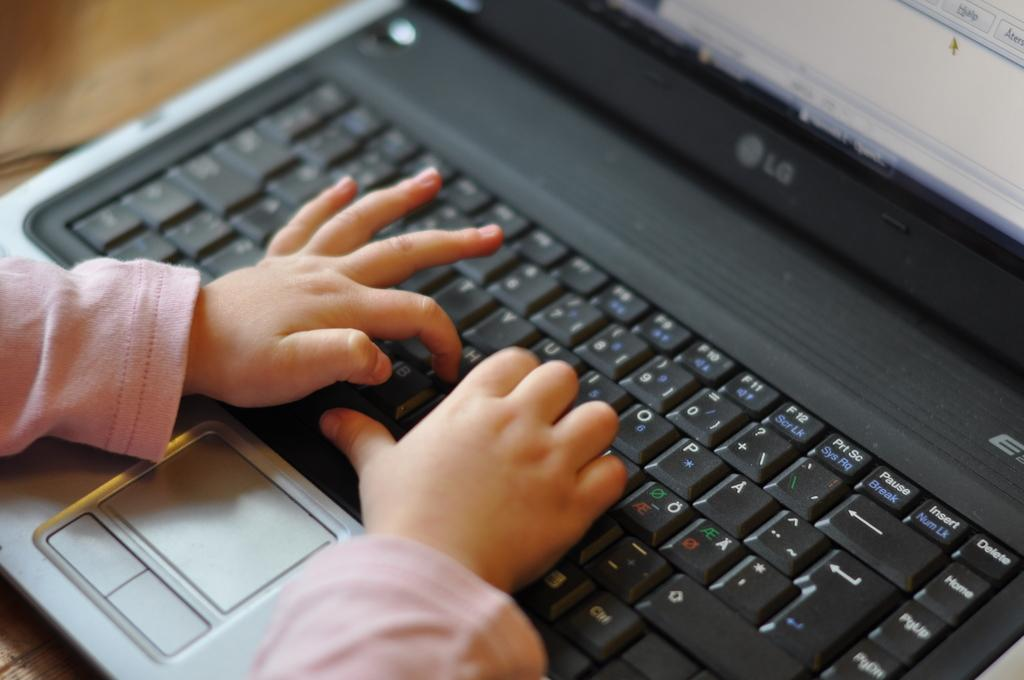<image>
Write a terse but informative summary of the picture. A baby types on a laptop keyboard by pressing the 'H' button. 